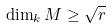Convert formula to latex. <formula><loc_0><loc_0><loc_500><loc_500>\dim _ { k } M \geq \sqrt { r }</formula> 